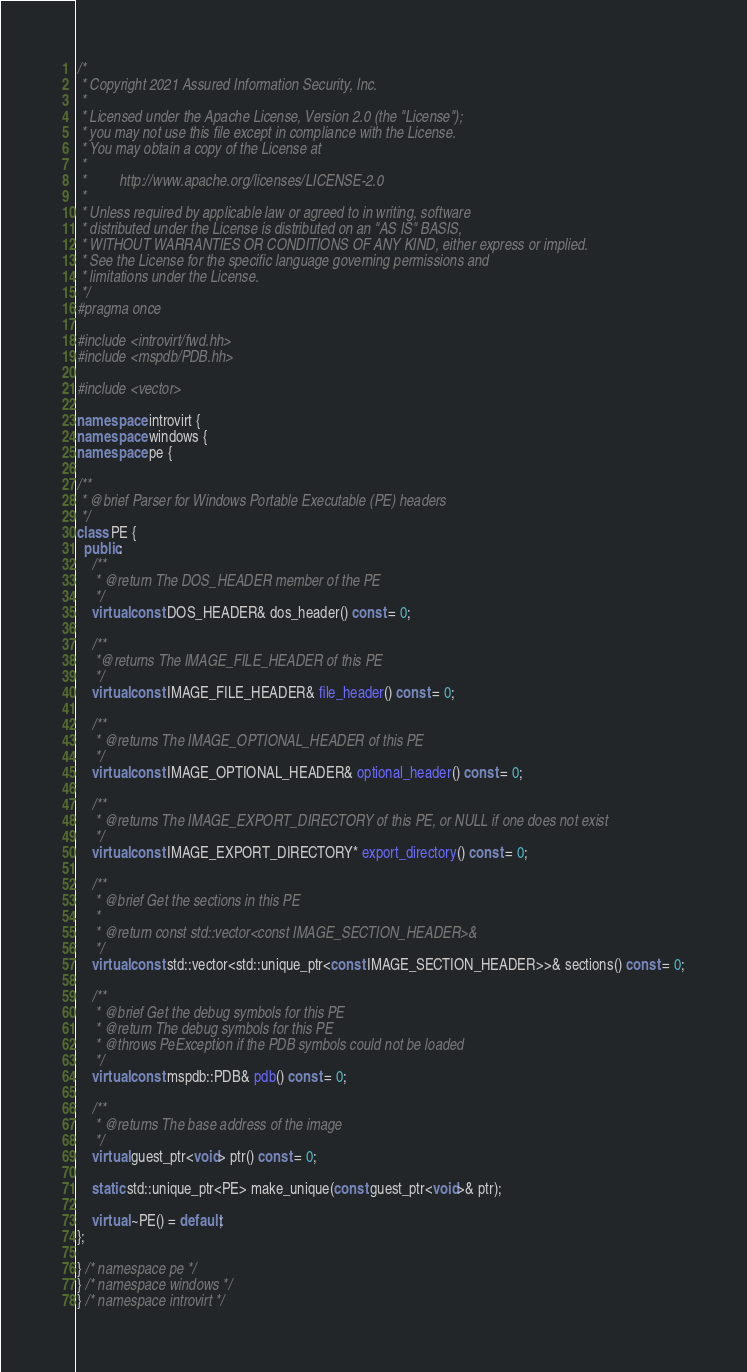<code> <loc_0><loc_0><loc_500><loc_500><_C++_>/*
 * Copyright 2021 Assured Information Security, Inc.
 *
 * Licensed under the Apache License, Version 2.0 (the "License");
 * you may not use this file except in compliance with the License.
 * You may obtain a copy of the License at
 *
 *         http://www.apache.org/licenses/LICENSE-2.0
 *
 * Unless required by applicable law or agreed to in writing, software
 * distributed under the License is distributed on an "AS IS" BASIS,
 * WITHOUT WARRANTIES OR CONDITIONS OF ANY KIND, either express or implied.
 * See the License for the specific language governing permissions and
 * limitations under the License.
 */
#pragma once

#include <introvirt/fwd.hh>
#include <mspdb/PDB.hh>

#include <vector>

namespace introvirt {
namespace windows {
namespace pe {

/**
 * @brief Parser for Windows Portable Executable (PE) headers
 */
class PE {
  public:
    /**
     * @return The DOS_HEADER member of the PE
     */
    virtual const DOS_HEADER& dos_header() const = 0;

    /**
     *@returns The IMAGE_FILE_HEADER of this PE
     */
    virtual const IMAGE_FILE_HEADER& file_header() const = 0;

    /**
     * @returns The IMAGE_OPTIONAL_HEADER of this PE
     */
    virtual const IMAGE_OPTIONAL_HEADER& optional_header() const = 0;

    /**
     * @returns The IMAGE_EXPORT_DIRECTORY of this PE, or NULL if one does not exist
     */
    virtual const IMAGE_EXPORT_DIRECTORY* export_directory() const = 0;

    /**
     * @brief Get the sections in this PE
     *
     * @return const std::vector<const IMAGE_SECTION_HEADER>&
     */
    virtual const std::vector<std::unique_ptr<const IMAGE_SECTION_HEADER>>& sections() const = 0;

    /**
     * @brief Get the debug symbols for this PE
     * @return The debug symbols for this PE
     * @throws PeException if the PDB symbols could not be loaded
     */
    virtual const mspdb::PDB& pdb() const = 0;

    /**
     * @returns The base address of the image
     */
    virtual guest_ptr<void> ptr() const = 0;

    static std::unique_ptr<PE> make_unique(const guest_ptr<void>& ptr);

    virtual ~PE() = default;
};

} /* namespace pe */
} /* namespace windows */
} /* namespace introvirt */
</code> 